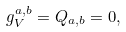Convert formula to latex. <formula><loc_0><loc_0><loc_500><loc_500>g ^ { a , b } _ { V } = Q _ { a , b } = 0 ,</formula> 